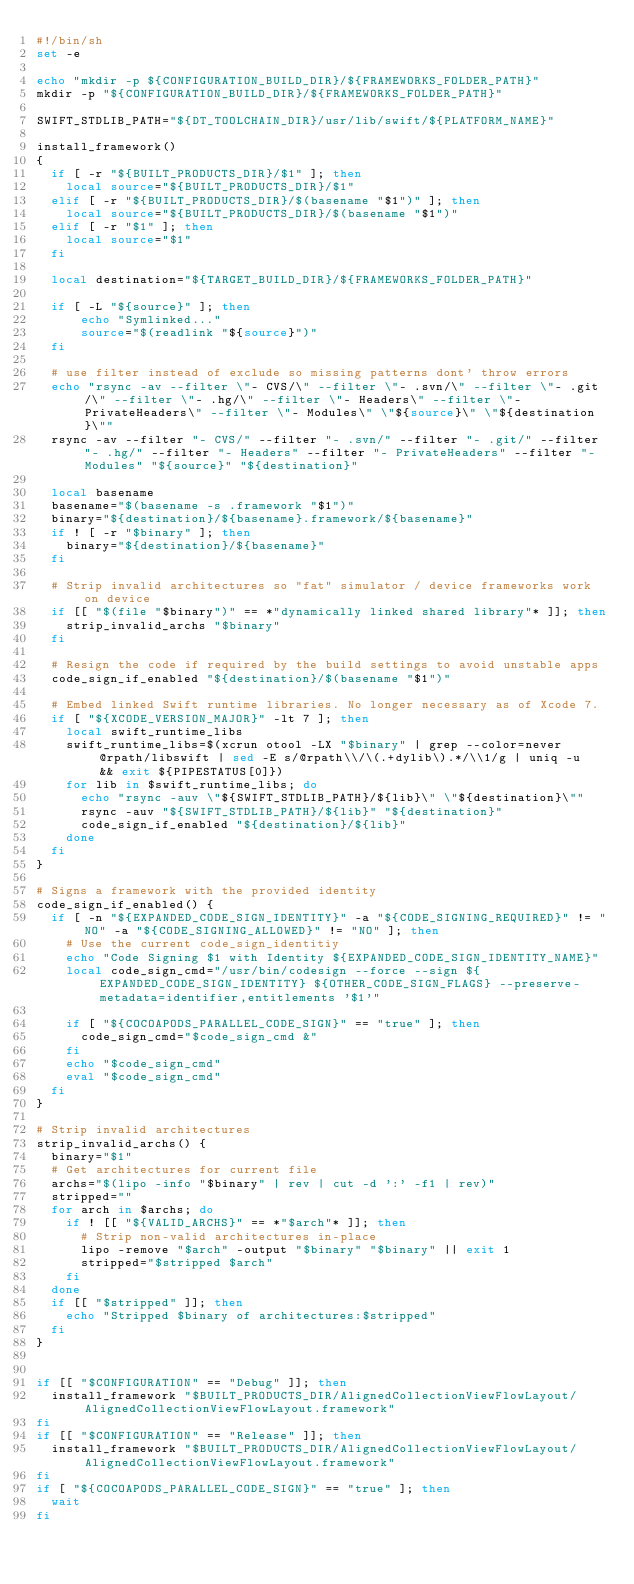Convert code to text. <code><loc_0><loc_0><loc_500><loc_500><_Bash_>#!/bin/sh
set -e

echo "mkdir -p ${CONFIGURATION_BUILD_DIR}/${FRAMEWORKS_FOLDER_PATH}"
mkdir -p "${CONFIGURATION_BUILD_DIR}/${FRAMEWORKS_FOLDER_PATH}"

SWIFT_STDLIB_PATH="${DT_TOOLCHAIN_DIR}/usr/lib/swift/${PLATFORM_NAME}"

install_framework()
{
  if [ -r "${BUILT_PRODUCTS_DIR}/$1" ]; then
    local source="${BUILT_PRODUCTS_DIR}/$1"
  elif [ -r "${BUILT_PRODUCTS_DIR}/$(basename "$1")" ]; then
    local source="${BUILT_PRODUCTS_DIR}/$(basename "$1")"
  elif [ -r "$1" ]; then
    local source="$1"
  fi

  local destination="${TARGET_BUILD_DIR}/${FRAMEWORKS_FOLDER_PATH}"

  if [ -L "${source}" ]; then
      echo "Symlinked..."
      source="$(readlink "${source}")"
  fi

  # use filter instead of exclude so missing patterns dont' throw errors
  echo "rsync -av --filter \"- CVS/\" --filter \"- .svn/\" --filter \"- .git/\" --filter \"- .hg/\" --filter \"- Headers\" --filter \"- PrivateHeaders\" --filter \"- Modules\" \"${source}\" \"${destination}\""
  rsync -av --filter "- CVS/" --filter "- .svn/" --filter "- .git/" --filter "- .hg/" --filter "- Headers" --filter "- PrivateHeaders" --filter "- Modules" "${source}" "${destination}"

  local basename
  basename="$(basename -s .framework "$1")"
  binary="${destination}/${basename}.framework/${basename}"
  if ! [ -r "$binary" ]; then
    binary="${destination}/${basename}"
  fi

  # Strip invalid architectures so "fat" simulator / device frameworks work on device
  if [[ "$(file "$binary")" == *"dynamically linked shared library"* ]]; then
    strip_invalid_archs "$binary"
  fi

  # Resign the code if required by the build settings to avoid unstable apps
  code_sign_if_enabled "${destination}/$(basename "$1")"

  # Embed linked Swift runtime libraries. No longer necessary as of Xcode 7.
  if [ "${XCODE_VERSION_MAJOR}" -lt 7 ]; then
    local swift_runtime_libs
    swift_runtime_libs=$(xcrun otool -LX "$binary" | grep --color=never @rpath/libswift | sed -E s/@rpath\\/\(.+dylib\).*/\\1/g | uniq -u  && exit ${PIPESTATUS[0]})
    for lib in $swift_runtime_libs; do
      echo "rsync -auv \"${SWIFT_STDLIB_PATH}/${lib}\" \"${destination}\""
      rsync -auv "${SWIFT_STDLIB_PATH}/${lib}" "${destination}"
      code_sign_if_enabled "${destination}/${lib}"
    done
  fi
}

# Signs a framework with the provided identity
code_sign_if_enabled() {
  if [ -n "${EXPANDED_CODE_SIGN_IDENTITY}" -a "${CODE_SIGNING_REQUIRED}" != "NO" -a "${CODE_SIGNING_ALLOWED}" != "NO" ]; then
    # Use the current code_sign_identitiy
    echo "Code Signing $1 with Identity ${EXPANDED_CODE_SIGN_IDENTITY_NAME}"
    local code_sign_cmd="/usr/bin/codesign --force --sign ${EXPANDED_CODE_SIGN_IDENTITY} ${OTHER_CODE_SIGN_FLAGS} --preserve-metadata=identifier,entitlements '$1'"

    if [ "${COCOAPODS_PARALLEL_CODE_SIGN}" == "true" ]; then
      code_sign_cmd="$code_sign_cmd &"
    fi
    echo "$code_sign_cmd"
    eval "$code_sign_cmd"
  fi
}

# Strip invalid architectures
strip_invalid_archs() {
  binary="$1"
  # Get architectures for current file
  archs="$(lipo -info "$binary" | rev | cut -d ':' -f1 | rev)"
  stripped=""
  for arch in $archs; do
    if ! [[ "${VALID_ARCHS}" == *"$arch"* ]]; then
      # Strip non-valid architectures in-place
      lipo -remove "$arch" -output "$binary" "$binary" || exit 1
      stripped="$stripped $arch"
    fi
  done
  if [[ "$stripped" ]]; then
    echo "Stripped $binary of architectures:$stripped"
  fi
}


if [[ "$CONFIGURATION" == "Debug" ]]; then
  install_framework "$BUILT_PRODUCTS_DIR/AlignedCollectionViewFlowLayout/AlignedCollectionViewFlowLayout.framework"
fi
if [[ "$CONFIGURATION" == "Release" ]]; then
  install_framework "$BUILT_PRODUCTS_DIR/AlignedCollectionViewFlowLayout/AlignedCollectionViewFlowLayout.framework"
fi
if [ "${COCOAPODS_PARALLEL_CODE_SIGN}" == "true" ]; then
  wait
fi
</code> 